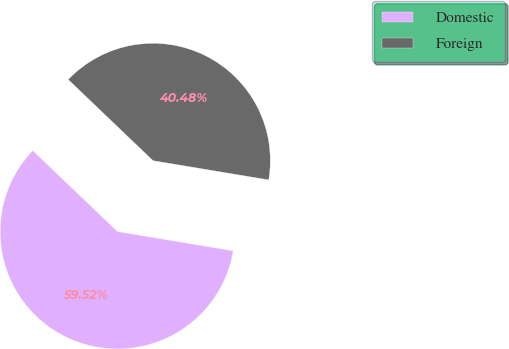Convert chart to OTSL. <chart><loc_0><loc_0><loc_500><loc_500><pie_chart><fcel>Domestic<fcel>Foreign<nl><fcel>59.52%<fcel>40.48%<nl></chart> 